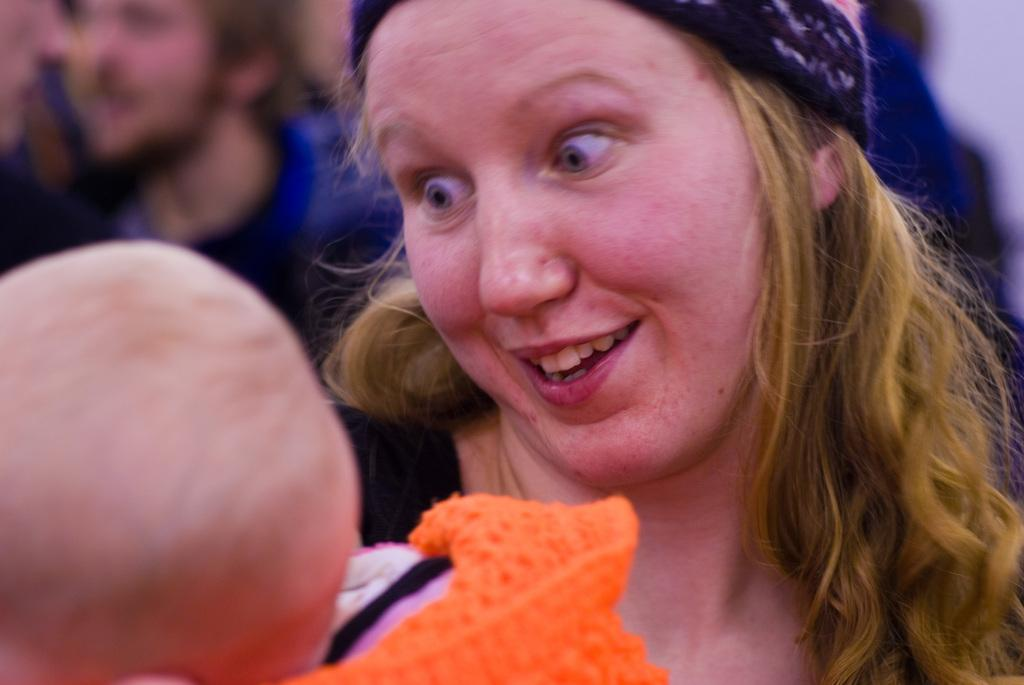Who is the main subject in the image? There is a lady in the center of the image. What is the lady doing in the image? The lady is holding a baby. Can you describe the lady's appearance? The lady is wearing a headband. What else can be seen in the image besides the lady and the baby? There are persons visible in the background of the image. How many dimes can be seen on the baby's forehead in the image? There are no dimes visible on the baby's forehead in the image. What type of writer is present in the image? There is no writer present in the image. 